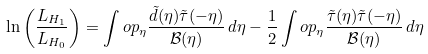<formula> <loc_0><loc_0><loc_500><loc_500>\ln \left ( \frac { L _ { H _ { 1 } } } { L _ { H _ { 0 } } } \right ) = \int o p _ { \eta } \frac { \tilde { d } ( \eta ) \tilde { \tau } ( - \eta ) } { \mathcal { B } ( \eta ) } \, d \eta - \frac { 1 } { 2 } \int o p _ { \eta } \frac { \tilde { \tau } ( \eta ) \tilde { \tau } ( - \eta ) } { \mathcal { B } ( \eta ) } \, d \eta</formula> 